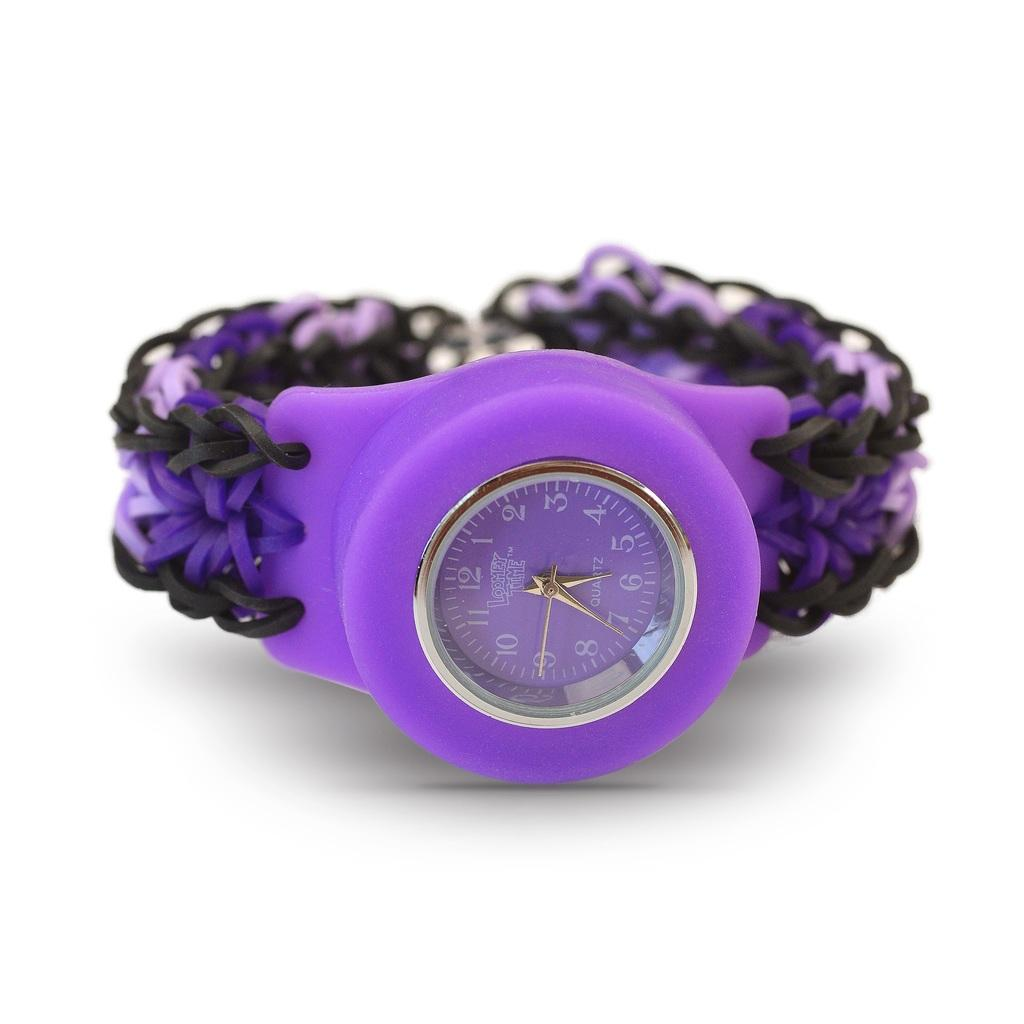<image>
Render a clear and concise summary of the photo. Purple watch which says QUARTZ on the face. 